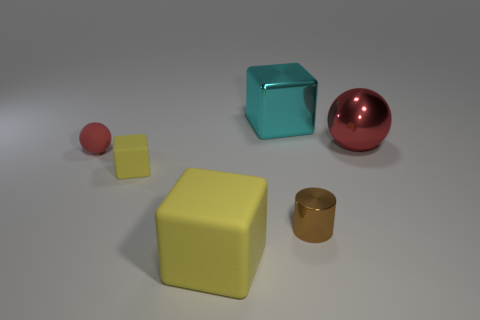Is the shape of the yellow object left of the large yellow thing the same as the red thing to the left of the metallic cube?
Your response must be concise. No. How many other things are the same color as the tiny rubber cube?
Ensure brevity in your answer.  1. Do the small thing that is right of the big yellow rubber block and the yellow thing that is behind the small metallic cylinder have the same material?
Provide a succinct answer. No. Is the number of metal objects in front of the cyan metallic thing the same as the number of big matte cubes to the left of the small yellow rubber cube?
Ensure brevity in your answer.  No. What material is the big block that is left of the shiny cube?
Your response must be concise. Rubber. Is there any other thing that is the same size as the rubber ball?
Offer a very short reply. Yes. Is the number of big spheres less than the number of blue rubber cylinders?
Provide a succinct answer. No. There is a metallic thing that is behind the small rubber block and left of the big metallic sphere; what is its shape?
Offer a terse response. Cube. What number of tiny brown metallic objects are there?
Keep it short and to the point. 1. There is a red object that is on the right side of the sphere to the left of the rubber thing that is in front of the small brown shiny thing; what is it made of?
Your response must be concise. Metal. 